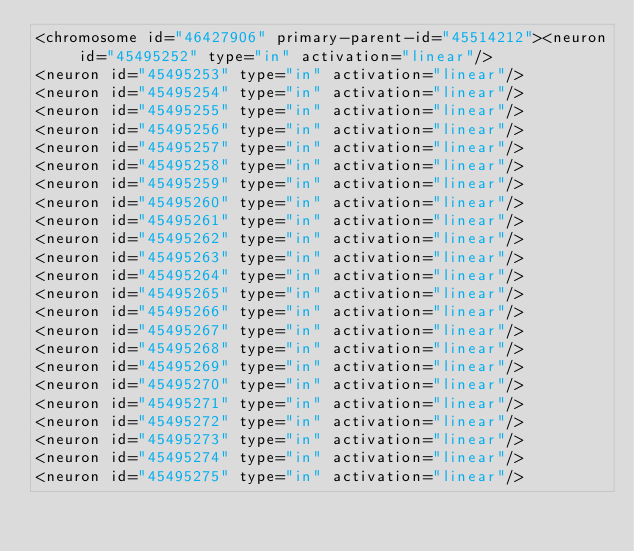<code> <loc_0><loc_0><loc_500><loc_500><_XML_><chromosome id="46427906" primary-parent-id="45514212"><neuron id="45495252" type="in" activation="linear"/>
<neuron id="45495253" type="in" activation="linear"/>
<neuron id="45495254" type="in" activation="linear"/>
<neuron id="45495255" type="in" activation="linear"/>
<neuron id="45495256" type="in" activation="linear"/>
<neuron id="45495257" type="in" activation="linear"/>
<neuron id="45495258" type="in" activation="linear"/>
<neuron id="45495259" type="in" activation="linear"/>
<neuron id="45495260" type="in" activation="linear"/>
<neuron id="45495261" type="in" activation="linear"/>
<neuron id="45495262" type="in" activation="linear"/>
<neuron id="45495263" type="in" activation="linear"/>
<neuron id="45495264" type="in" activation="linear"/>
<neuron id="45495265" type="in" activation="linear"/>
<neuron id="45495266" type="in" activation="linear"/>
<neuron id="45495267" type="in" activation="linear"/>
<neuron id="45495268" type="in" activation="linear"/>
<neuron id="45495269" type="in" activation="linear"/>
<neuron id="45495270" type="in" activation="linear"/>
<neuron id="45495271" type="in" activation="linear"/>
<neuron id="45495272" type="in" activation="linear"/>
<neuron id="45495273" type="in" activation="linear"/>
<neuron id="45495274" type="in" activation="linear"/>
<neuron id="45495275" type="in" activation="linear"/></code> 